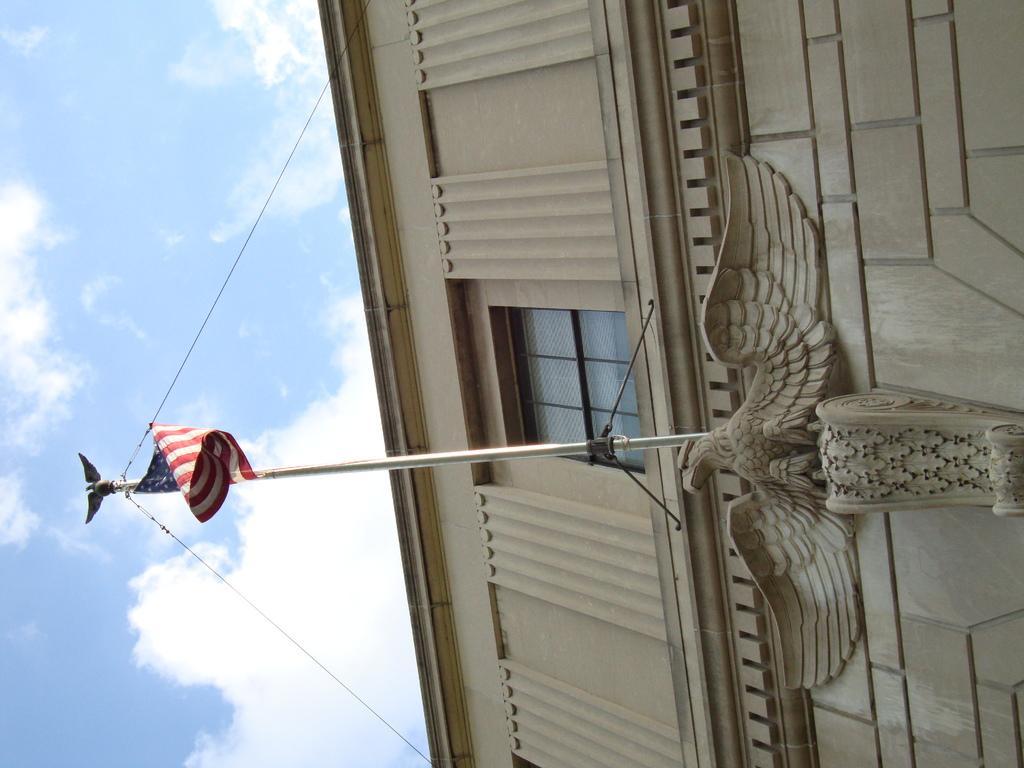How would you summarize this image in a sentence or two? This picture is clicked outside. In the the foreground we can see the sculpture of an eagle and we can see a flag attached to the pole, we can see the window and the wall of the building. In the background we can see the sky and the clouds. 